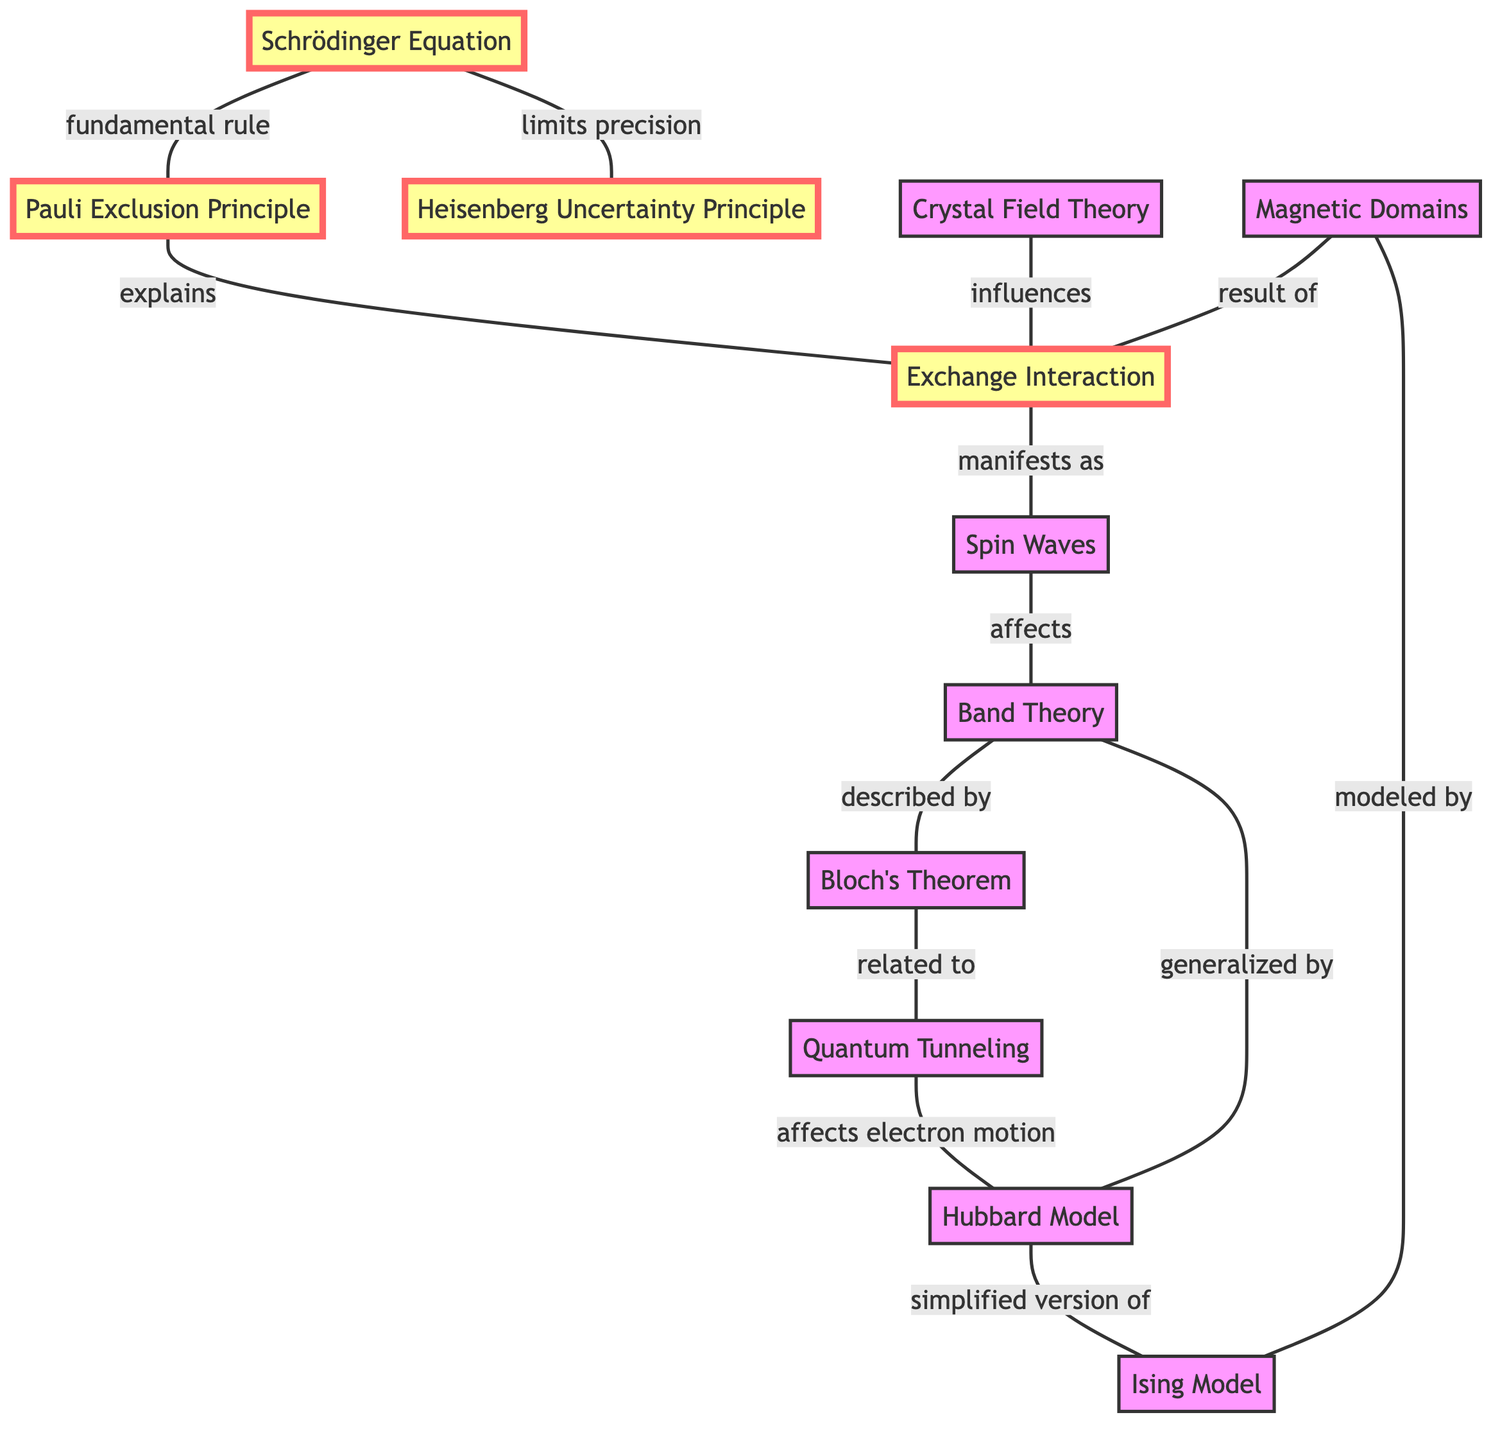What's the total number of nodes in the diagram? The diagram has 12 nodes identified by their unique IDs, including concepts like Schrödinger Equation, Pauli Exclusion Principle, and others, which are visually represented in the diagram.
Answer: 12 Which concept is influenced by Crystal Field Theory? According to the edges, Crystal Field Theory influences Exchange Interaction, linking the two concepts directly through the edge labeled "influences."
Answer: Exchange Interaction How many edges are connected to the Band Theory node? Band Theory is connected to two edges, one leading to Spin Waves with the label "affects" and another leading to Bloch's Theorem with the label "described by."
Answer: 2 Which node models Magnetic Domains? The edge labeled "modeled by" indicates that Magnetic Domains are modeled by the Ising Model, showing the relationship between the two nodes.
Answer: Ising Model What does the Schrödinger Equation limit according to the diagram? The edge connecting the Schrödinger Equation to the Heisenberg Uncertainty Principle is labeled "limits precision," showing that it places limitations on precision in measurements.
Answer: precision How does Quantum Tunneling relate to Bloch's Theorem? The diagram shows a direct relationship where Quantum Tunneling is related to Bloch's Theorem through an edge labeled "related to," indicating a conceptual link between the two.
Answer: related to Which concept serves as a simplified version of the Hubbard Model? The diagram directly indicates that the Ising Model serves as a simplified version of the Hubbard Model through the edge labeled "simplified version of."
Answer: Ising Model What is the result of Exchange Interaction? The edge connecting Magnetic Domains and Exchange Interaction is labeled "result of," clearly indicating that Magnetic Domains are a result of the Exchange Interaction.
Answer: Magnetic Domains How many principles are connected to the Schrödinger Equation? The Schrödinger Equation is connected to two principles: the Pauli Exclusion Principle and the Heisenberg Uncertainty Principle, forming direct relationships represented by edges.
Answer: 2 